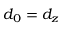Convert formula to latex. <formula><loc_0><loc_0><loc_500><loc_500>d _ { 0 } = d _ { z }</formula> 